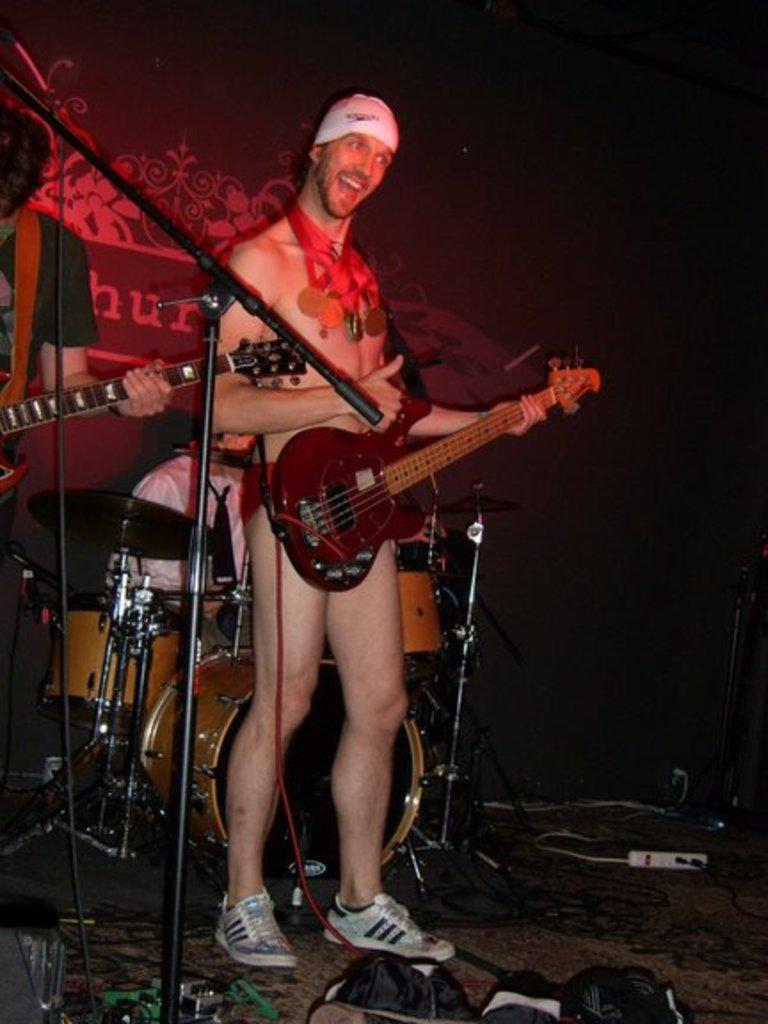What is the main activity happening in the image? There is a guy playing a guitar and another guy singing with a mic in the image. What event might the image be depicting? The image is from a musical concert. Can you describe the roles of the two guys in the image? One guy is playing a guitar, while the other is singing with a mic. What type of stone can be seen healing the wound in the image? There is no stone or wound present in the image; it features a guy playing a guitar and another guy singing with a mic at a musical concert. 